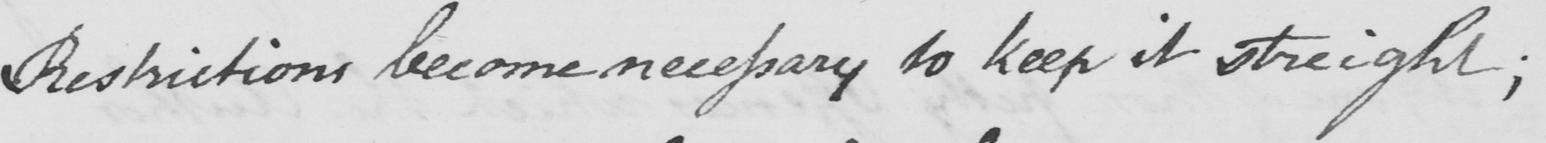Transcribe the text shown in this historical manuscript line. Restrictions become necessary to keep it streight ; 